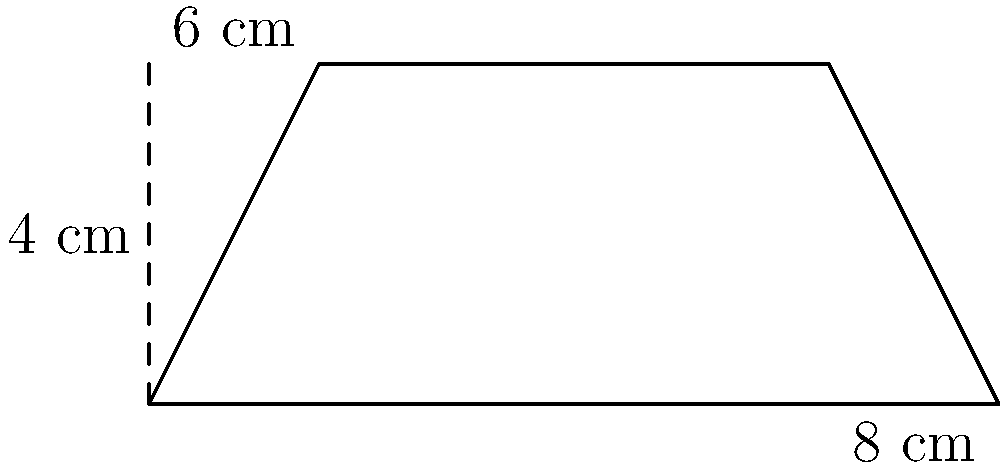For the upcoming local biographer's award ceremony, you need to design a trapezoid-shaped plaque. The plaque's base measures 8 cm, its top measures 6 cm, and its height is 4 cm. What is the area of this plaque in square centimeters? To find the area of a trapezoid, we use the formula:

$$A = \frac{1}{2}(b_1 + b_2)h$$

Where:
$A$ = Area
$b_1$ = Length of one parallel side
$b_2$ = Length of the other parallel side
$h$ = Height (perpendicular distance between the parallel sides)

Given:
$b_1 = 8$ cm (base)
$b_2 = 6$ cm (top)
$h = 4$ cm (height)

Let's substitute these values into the formula:

$$A = \frac{1}{2}(8 + 6) \times 4$$

$$A = \frac{1}{2}(14) \times 4$$

$$A = 7 \times 4$$

$$A = 28$$

Therefore, the area of the trapezoid-shaped plaque is 28 square centimeters.
Answer: 28 cm² 